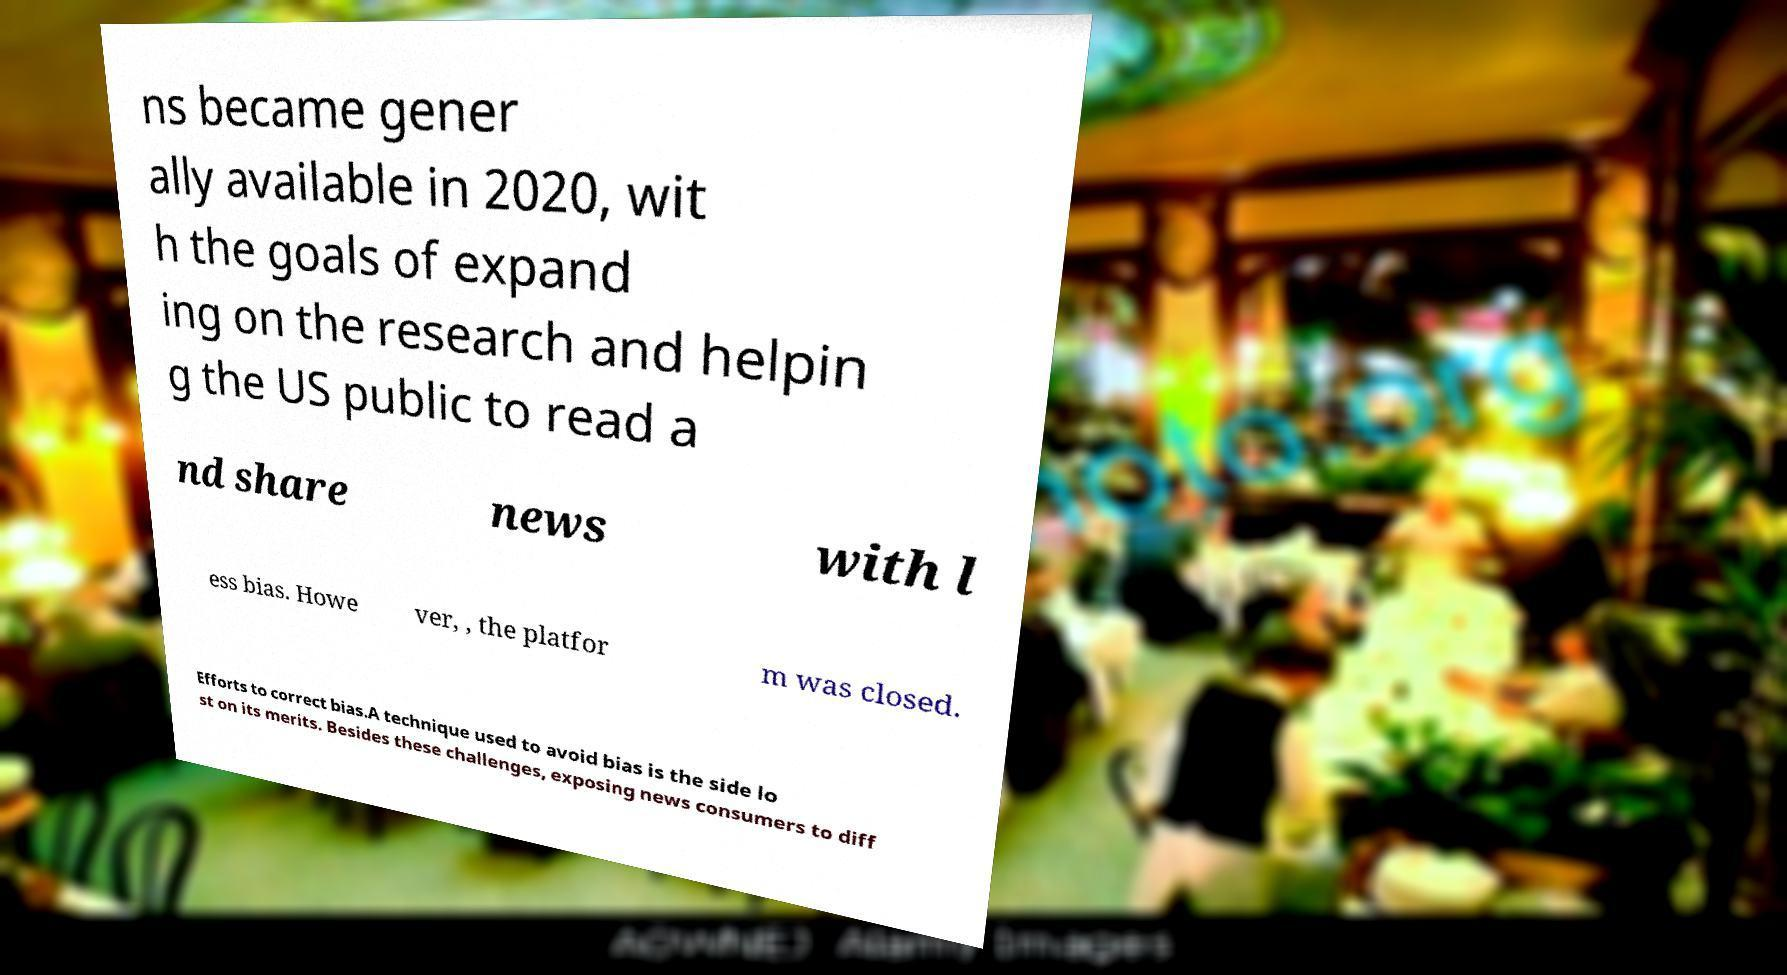Can you read and provide the text displayed in the image?This photo seems to have some interesting text. Can you extract and type it out for me? ns became gener ally available in 2020, wit h the goals of expand ing on the research and helpin g the US public to read a nd share news with l ess bias. Howe ver, , the platfor m was closed. Efforts to correct bias.A technique used to avoid bias is the side lo st on its merits. Besides these challenges, exposing news consumers to diff 